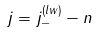Convert formula to latex. <formula><loc_0><loc_0><loc_500><loc_500>j = j _ { - } ^ { \left ( l w \right ) } - n</formula> 